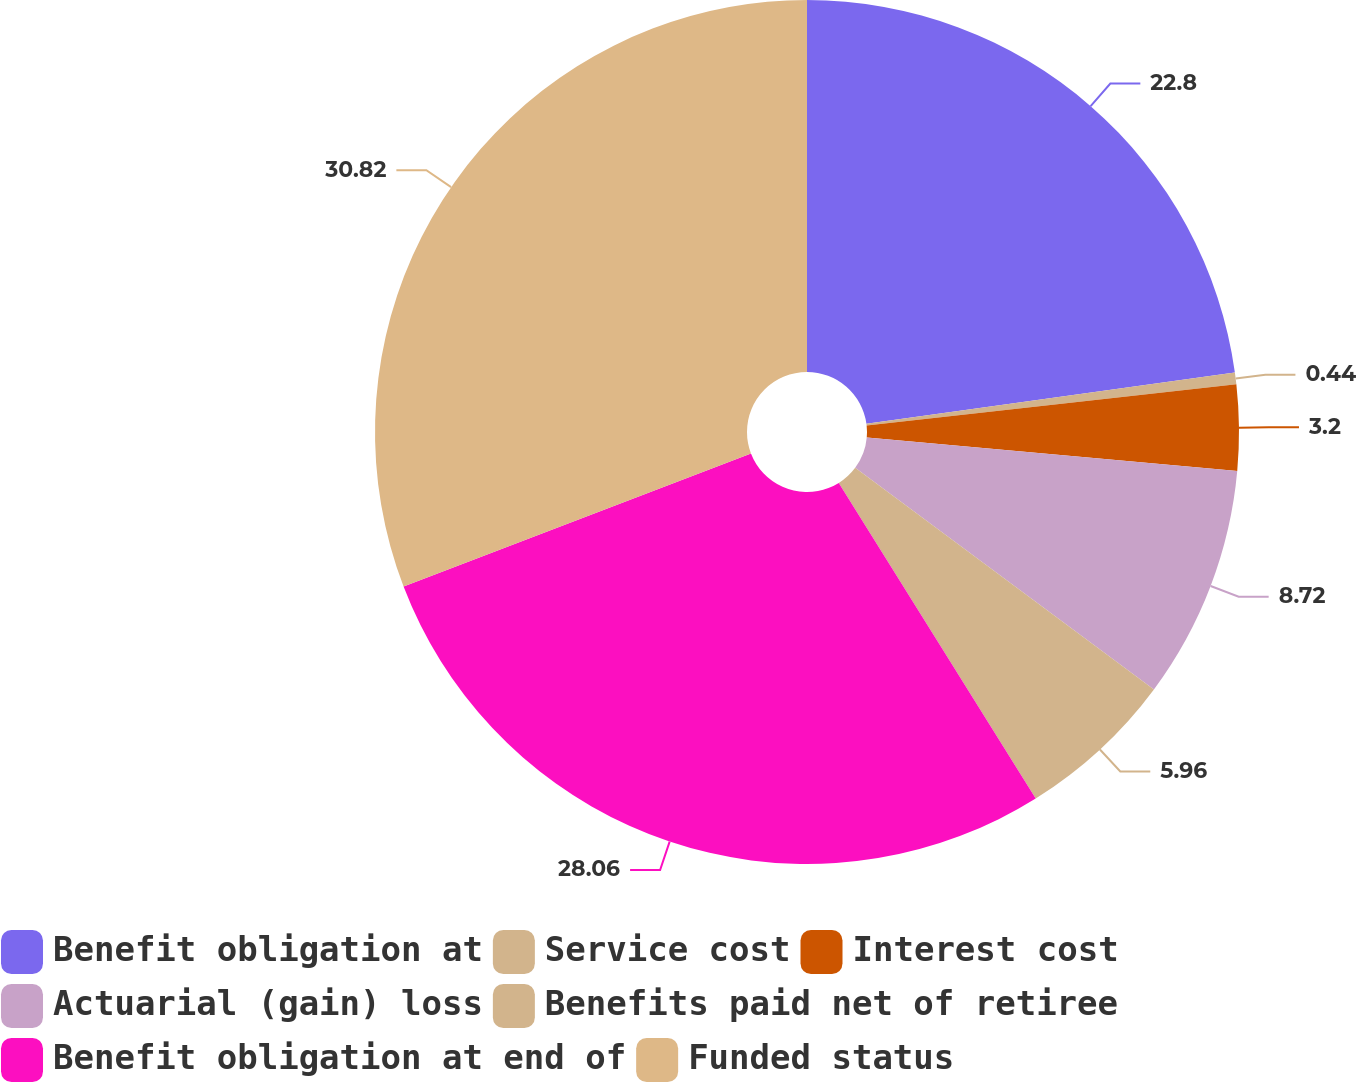<chart> <loc_0><loc_0><loc_500><loc_500><pie_chart><fcel>Benefit obligation at<fcel>Service cost<fcel>Interest cost<fcel>Actuarial (gain) loss<fcel>Benefits paid net of retiree<fcel>Benefit obligation at end of<fcel>Funded status<nl><fcel>22.8%<fcel>0.44%<fcel>3.2%<fcel>8.72%<fcel>5.96%<fcel>28.06%<fcel>30.82%<nl></chart> 